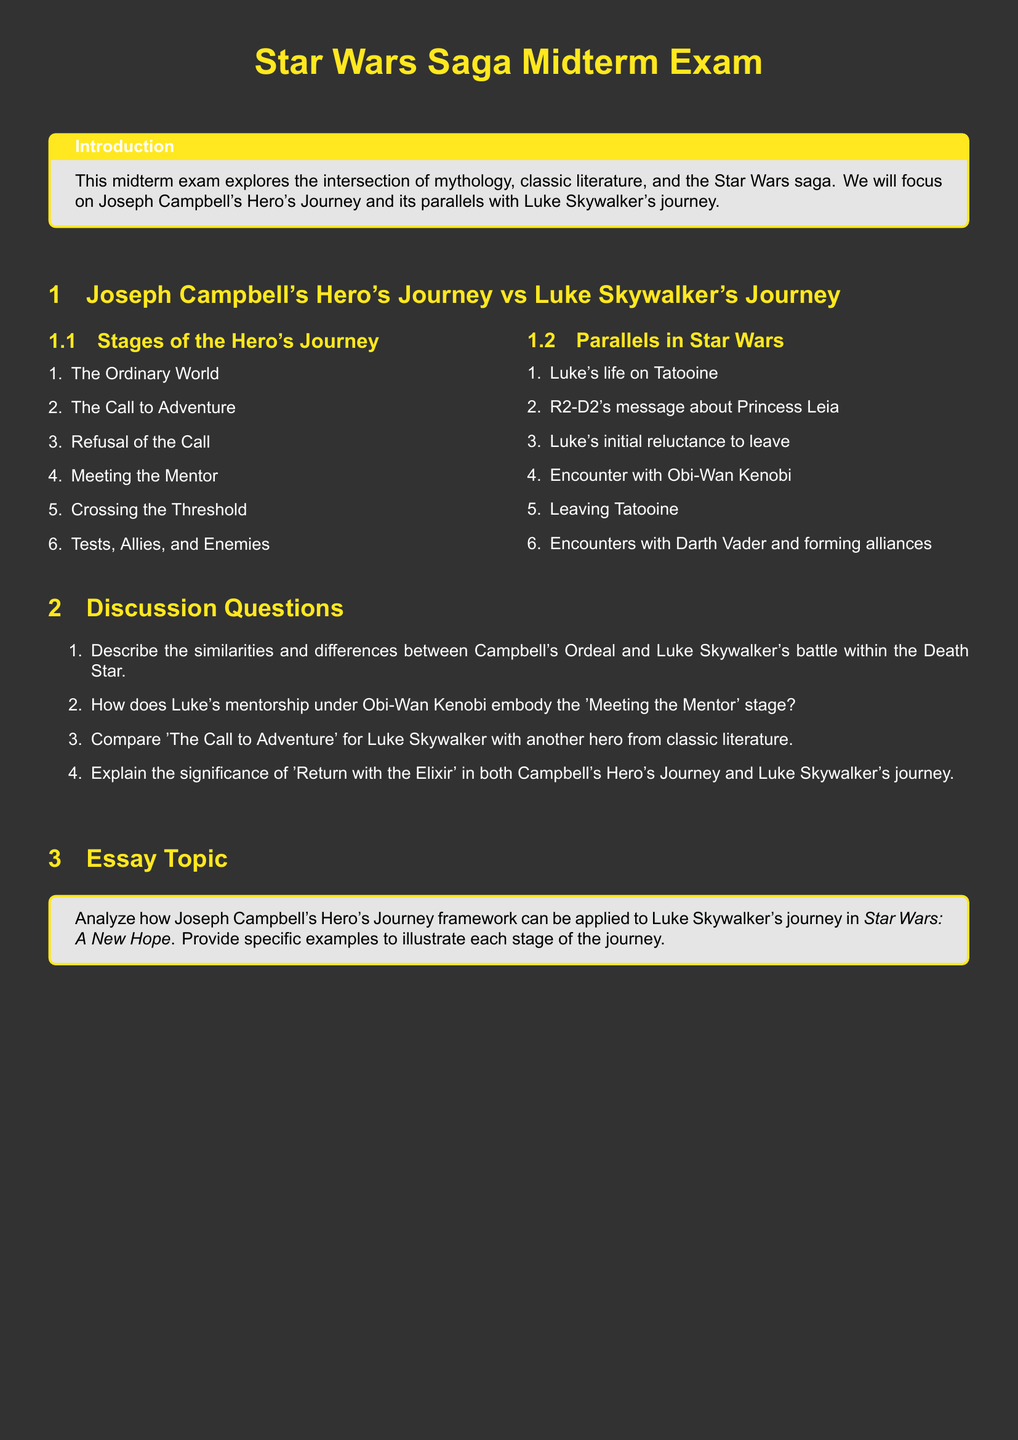What are the first two stages of the Hero's Journey? The document lists the stages in a specific order and the first two are provided.
Answer: The Ordinary World, The Call to Adventure Who is Luke's mentor according to the document? The document specifies the character who plays a mentorship role for Luke.
Answer: Obi-Wan Kenobi In which location does Luke's journey begin? The document explicitly states where Luke's story starts.
Answer: Tatooine How many stages are mentioned in the Hero's Journey? The document counts and lists the stages of the Hero's Journey.
Answer: Six What is the essay topic focused on? The document provides a clear prompt for the essay.
Answer: Joseph Campbell's Hero's Journey framework and Luke Skywalker's journey What stage corresponds to Luke's initial reluctance to leave? The document aligns specific stages of the Hero's Journey with Luke's actions.
Answer: Refusal of the Call What is the significance of 'Return with the Elixir'? The document discusses the importance of this stage in both contexts.
Answer: Both Luke Skywalker’s journey and Campbell's Hero's Journey How is R2-D2's message described in the context of Luke's adventure? The document describes the role of R2-D2's message in relation to adventure.
Answer: Call to Adventure 